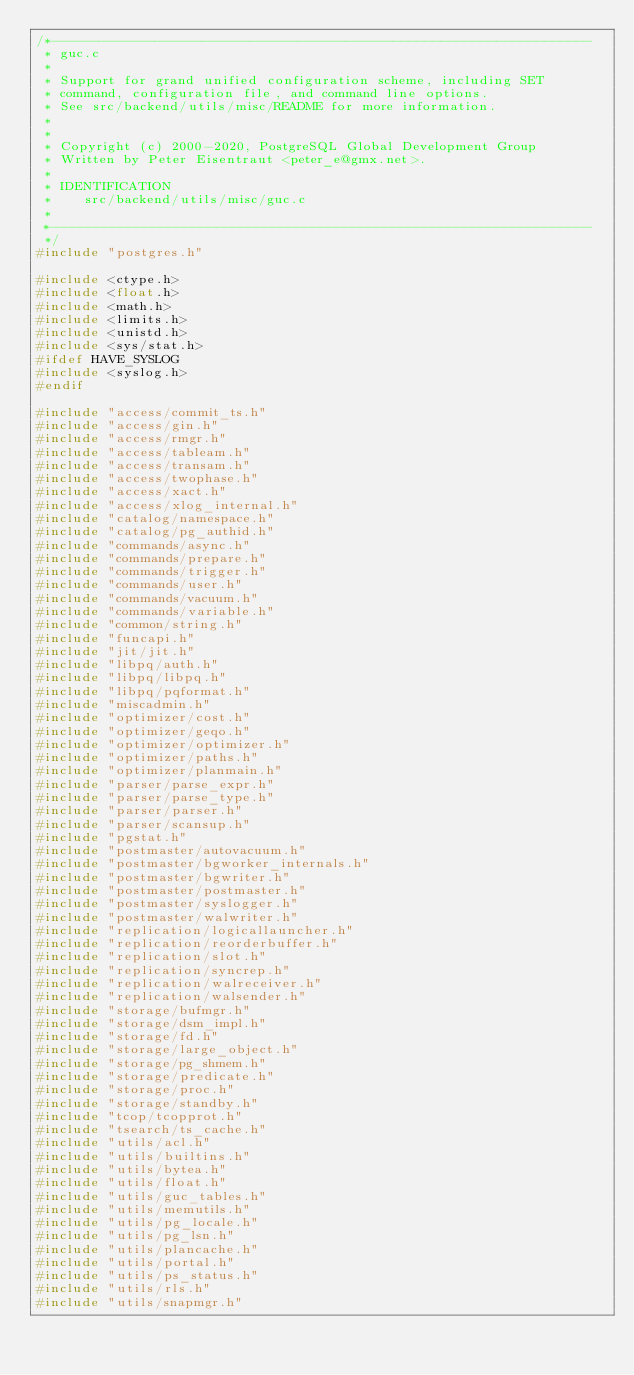Convert code to text. <code><loc_0><loc_0><loc_500><loc_500><_C_>/*--------------------------------------------------------------------
 * guc.c
 *
 * Support for grand unified configuration scheme, including SET
 * command, configuration file, and command line options.
 * See src/backend/utils/misc/README for more information.
 *
 *
 * Copyright (c) 2000-2020, PostgreSQL Global Development Group
 * Written by Peter Eisentraut <peter_e@gmx.net>.
 *
 * IDENTIFICATION
 *	  src/backend/utils/misc/guc.c
 *
 *--------------------------------------------------------------------
 */
#include "postgres.h"

#include <ctype.h>
#include <float.h>
#include <math.h>
#include <limits.h>
#include <unistd.h>
#include <sys/stat.h>
#ifdef HAVE_SYSLOG
#include <syslog.h>
#endif

#include "access/commit_ts.h"
#include "access/gin.h"
#include "access/rmgr.h"
#include "access/tableam.h"
#include "access/transam.h"
#include "access/twophase.h"
#include "access/xact.h"
#include "access/xlog_internal.h"
#include "catalog/namespace.h"
#include "catalog/pg_authid.h"
#include "commands/async.h"
#include "commands/prepare.h"
#include "commands/trigger.h"
#include "commands/user.h"
#include "commands/vacuum.h"
#include "commands/variable.h"
#include "common/string.h"
#include "funcapi.h"
#include "jit/jit.h"
#include "libpq/auth.h"
#include "libpq/libpq.h"
#include "libpq/pqformat.h"
#include "miscadmin.h"
#include "optimizer/cost.h"
#include "optimizer/geqo.h"
#include "optimizer/optimizer.h"
#include "optimizer/paths.h"
#include "optimizer/planmain.h"
#include "parser/parse_expr.h"
#include "parser/parse_type.h"
#include "parser/parser.h"
#include "parser/scansup.h"
#include "pgstat.h"
#include "postmaster/autovacuum.h"
#include "postmaster/bgworker_internals.h"
#include "postmaster/bgwriter.h"
#include "postmaster/postmaster.h"
#include "postmaster/syslogger.h"
#include "postmaster/walwriter.h"
#include "replication/logicallauncher.h"
#include "replication/reorderbuffer.h"
#include "replication/slot.h"
#include "replication/syncrep.h"
#include "replication/walreceiver.h"
#include "replication/walsender.h"
#include "storage/bufmgr.h"
#include "storage/dsm_impl.h"
#include "storage/fd.h"
#include "storage/large_object.h"
#include "storage/pg_shmem.h"
#include "storage/predicate.h"
#include "storage/proc.h"
#include "storage/standby.h"
#include "tcop/tcopprot.h"
#include "tsearch/ts_cache.h"
#include "utils/acl.h"
#include "utils/builtins.h"
#include "utils/bytea.h"
#include "utils/float.h"
#include "utils/guc_tables.h"
#include "utils/memutils.h"
#include "utils/pg_locale.h"
#include "utils/pg_lsn.h"
#include "utils/plancache.h"
#include "utils/portal.h"
#include "utils/ps_status.h"
#include "utils/rls.h"
#include "utils/snapmgr.h"</code> 